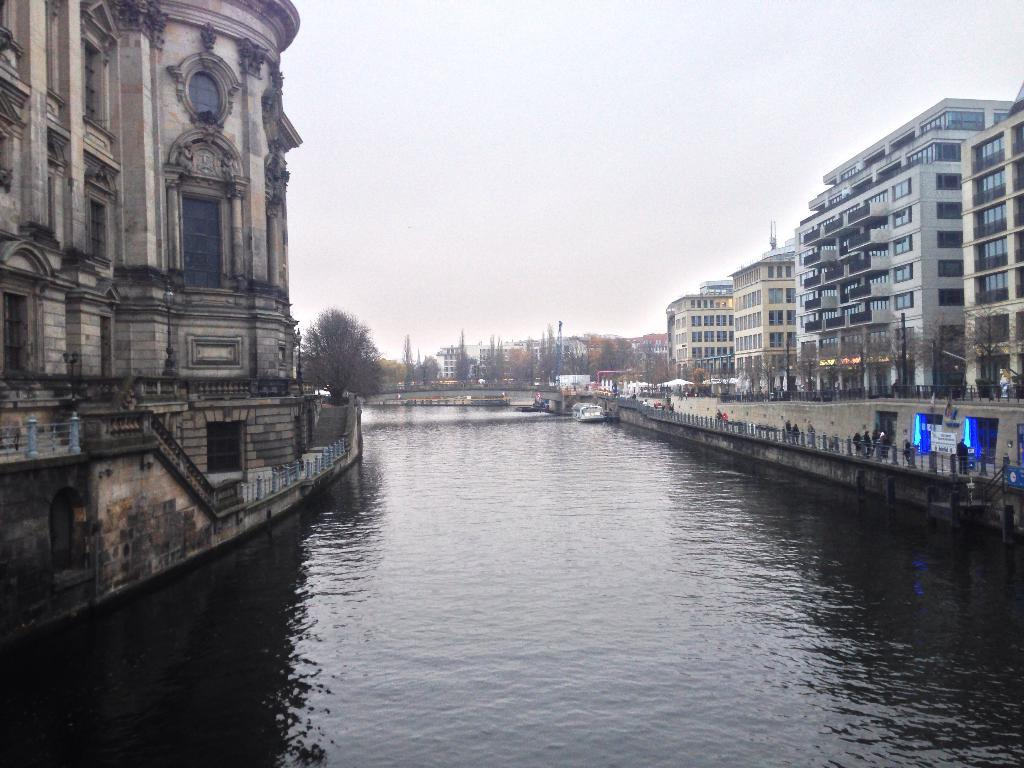Who or what can be seen in the image? There are people in the image. What type of structures are present in the image? There are buildings in the image. What natural elements can be seen in the image? There are trees in the image. What man-made objects are present in the image? There are poles and boards in the image. What is the water in the image like? There is water with objects in the image. What type of barrier is visible in the image? There is a fence in the image. What part of the natural environment is visible in the image? The sky is visible in the image. What type of pie is being served on the carriage in the image? There is no pie or carriage present in the image. 